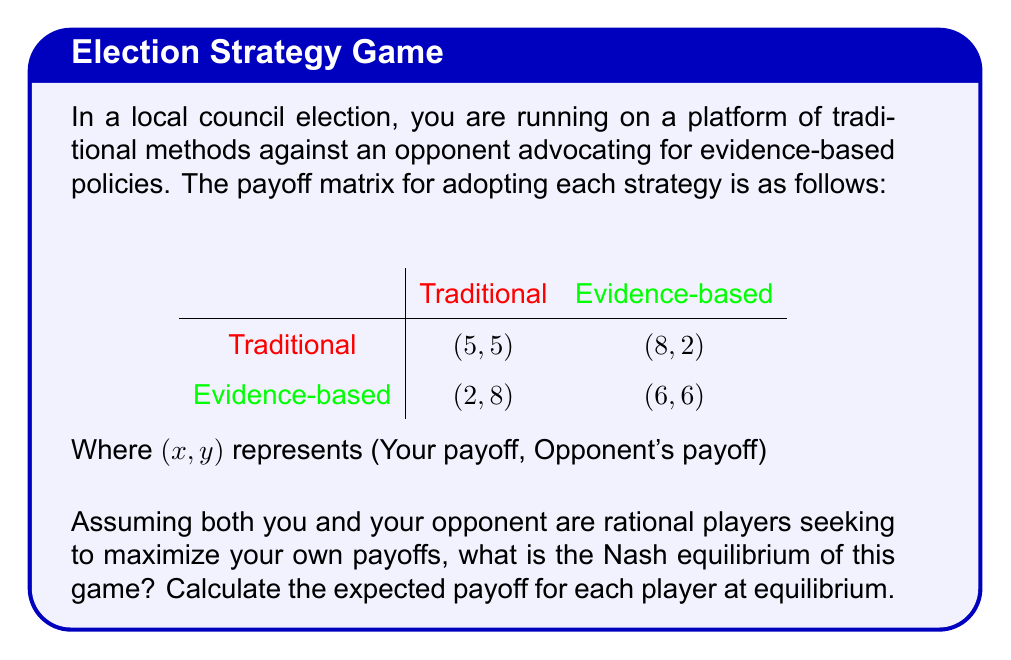What is the answer to this math problem? To solve this game theory problem, we need to find the Nash equilibrium, which is a state where neither player can unilaterally change their strategy to increase their payoff.

Step 1: Identify dominant strategies
- For you (row player):
  - If opponent chooses Traditional: 5 > 2, so you choose Traditional
  - If opponent chooses Evidence-based: 8 > 6, so you choose Traditional
  Traditional is your dominant strategy.

- For opponent (column player):
  - If you choose Traditional: 8 > 5, so opponent chooses Evidence-based
  - If you choose Evidence-based: 6 > 2, so opponent chooses Evidence-based
  Evidence-based is opponent's dominant strategy.

Step 2: Determine Nash equilibrium
Since both players have dominant strategies, the Nash equilibrium is where you play Traditional and your opponent plays Evidence-based.

Step 3: Calculate payoffs at equilibrium
At the Nash equilibrium (Traditional, Evidence-based), the payoffs are:
- Your payoff: 8
- Opponent's payoff: 2

Therefore, the expected payoff for each player at equilibrium is:
- Your expected payoff: 8
- Opponent's expected payoff: 2
Answer: The Nash equilibrium is (Traditional, Evidence-based) with expected payoffs of 8 for you and 2 for your opponent. 